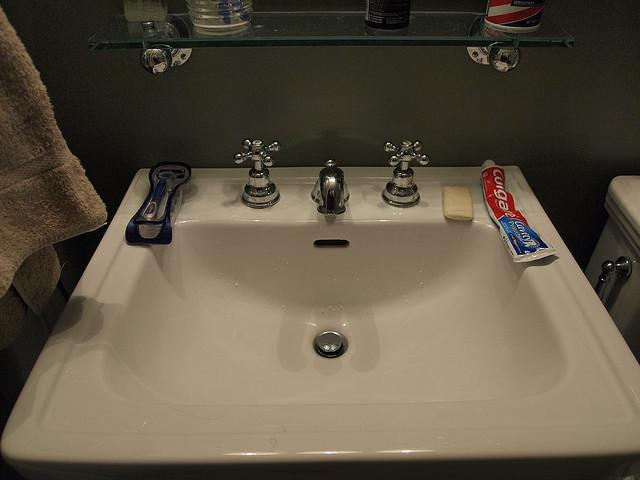What will they squeeze the substance in the tube onto? Please explain your reasoning. toothbrush. Toothpaste is typically applied directly to a toothbrush. 